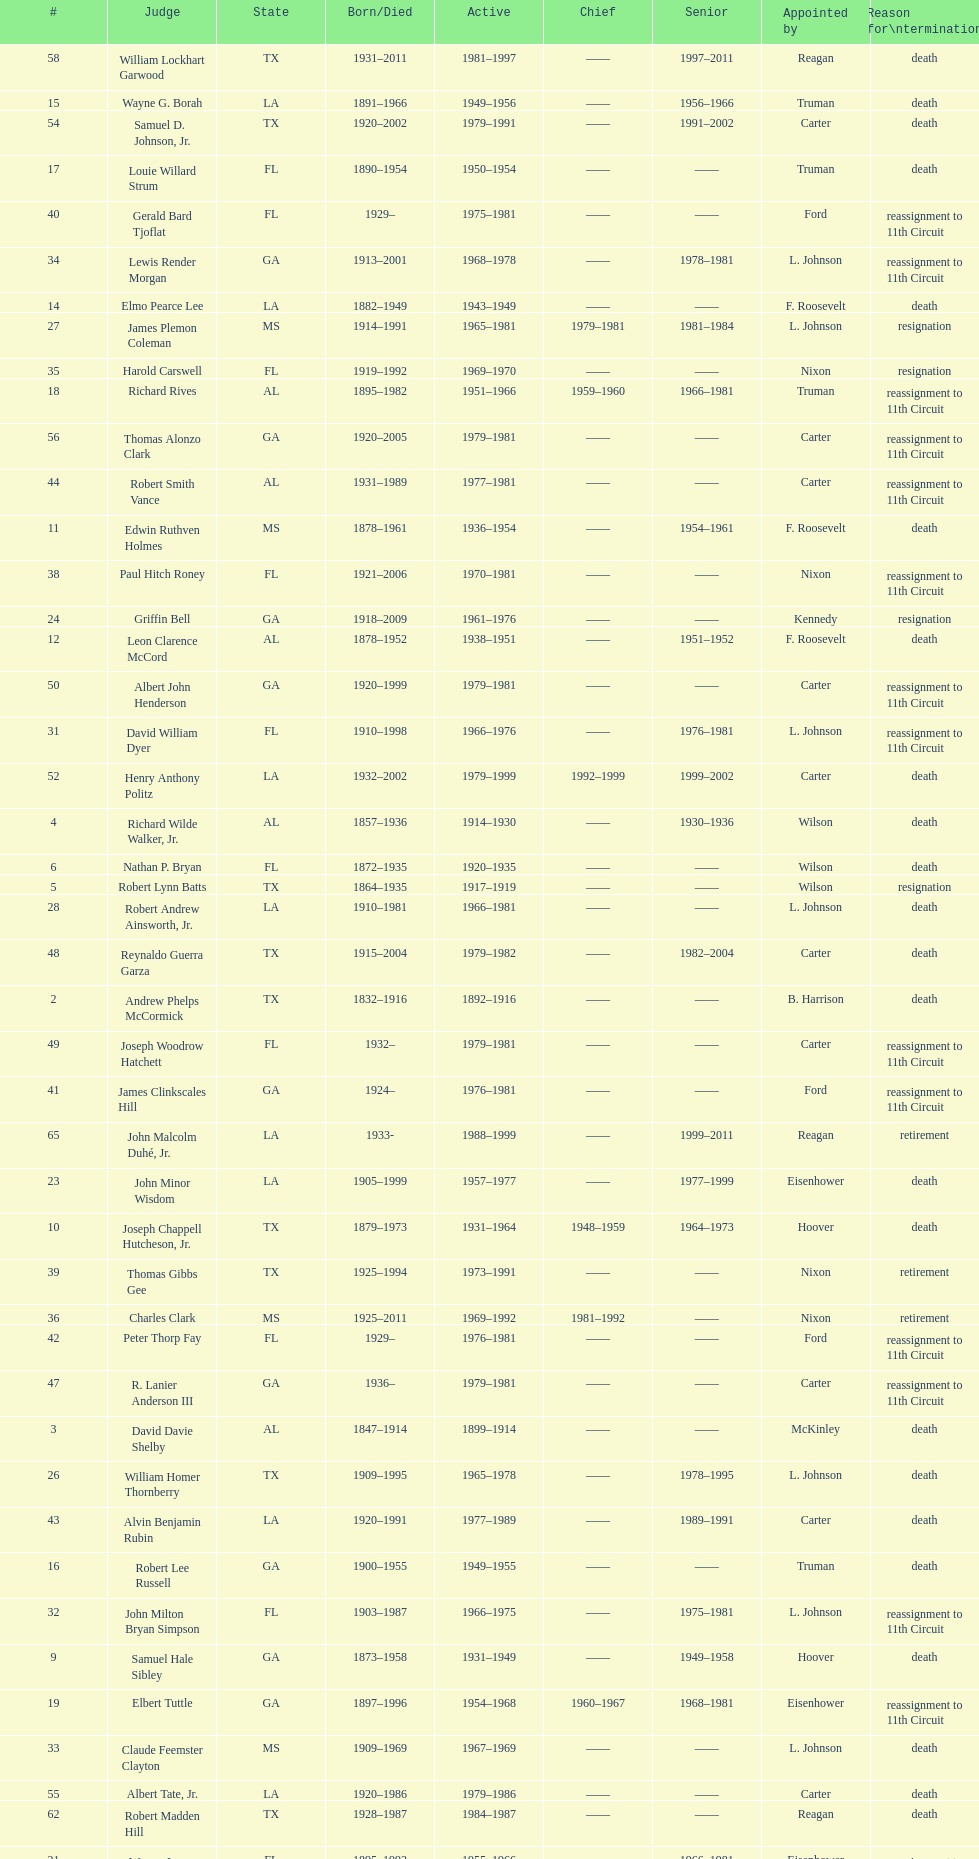How many judges served as chief total? 8. 